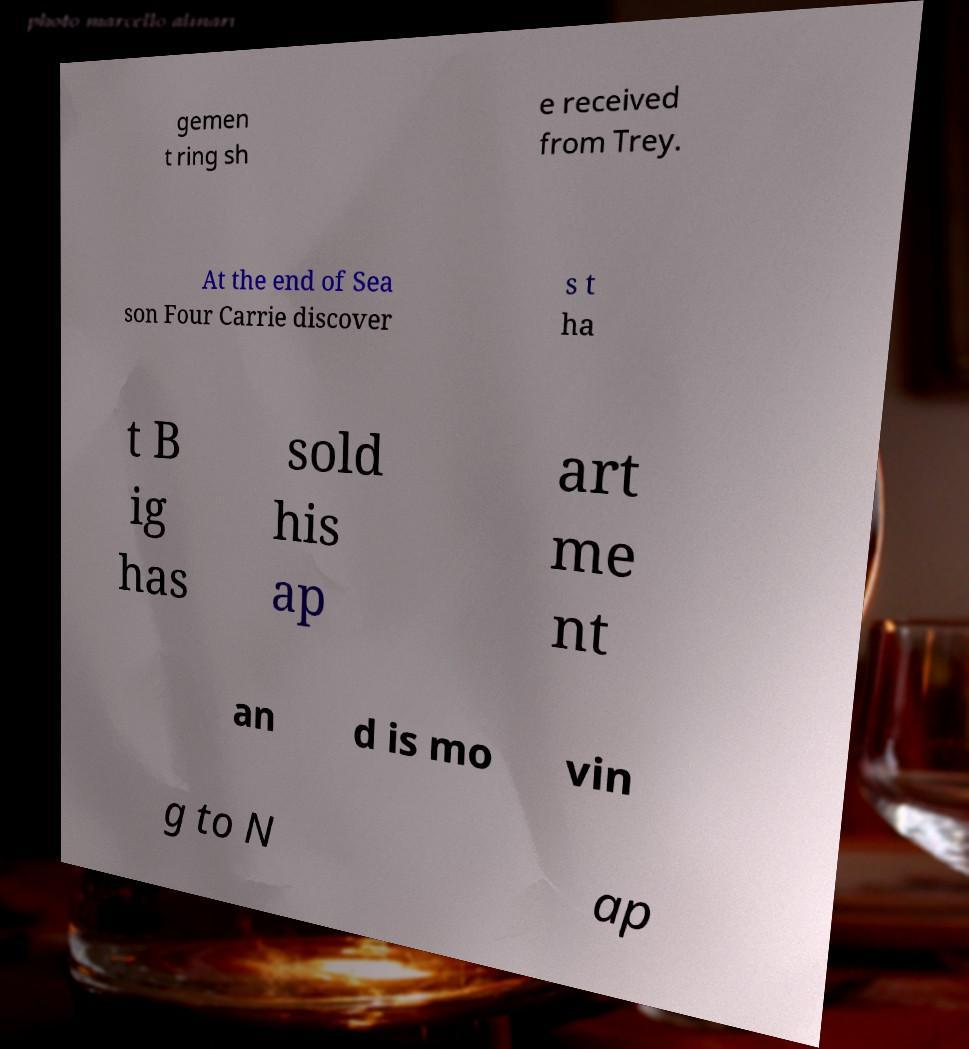Could you extract and type out the text from this image? gemen t ring sh e received from Trey. At the end of Sea son Four Carrie discover s t ha t B ig has sold his ap art me nt an d is mo vin g to N ap 